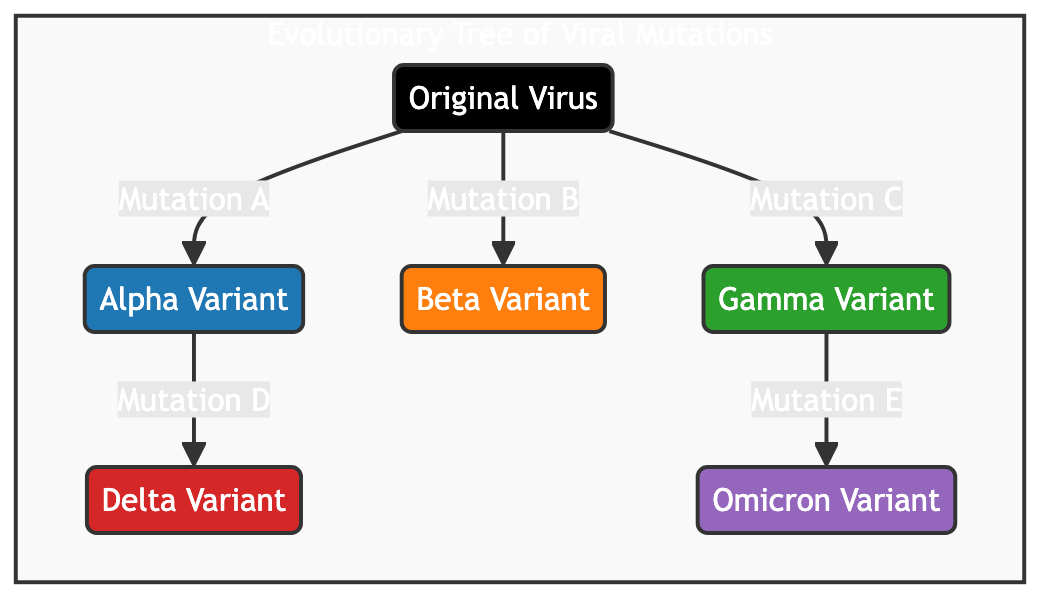What is the original virus labeled as? The original virus is depicted as the root of the evolutionary tree, specifically labeled as "Original Virus."
Answer: Original Virus How many variants are derived from the original virus? The diagram shows five variants branching from the original virus: Alpha, Beta, Gamma, Delta, and Omicron. Therefore, there are a total of five variants derived from the original virus.
Answer: 5 Which mutation leads to the Delta variant? The Delta variant is accessible through the Alpha variant, as indicated by the edge labeled "Mutation D" that connects them.
Answer: Mutation D What mutation is responsible for the emergence of the Beta variant? The connection to the Beta variant from the original virus is labeled "Mutation B," indicating that this mutation is responsible for its emergence.
Answer: Mutation B Which variants are directly derived from Gamma? The only variant that is directly derived from Gamma is the Omicron variant, shown in the diagram by the edge labeled "Mutation E."
Answer: Omicron If the original virus experiences Mutation C, which variant is produced? Following the mutation labeled "Mutation C," the diagram indicates that the Gamma variant is produced from the original virus.
Answer: Gamma Variant How many total mutations are depicted in the diagram? The mutations mapped in the diagram involve five connections: A, B, C, D, and E, thus representing a total of five mutations.
Answer: 5 Which variant has no further mutations after it? The Delta and Omicron variants do not show any further mutations leading from them in the evolutionary tree, meaning they are terminal points.
Answer: Delta Variant and Omicron Variant Which variant results from the Alpha variant? The tree structure shows that the Delta variant results from the Alpha variant through "Mutation D." Thus, the direct outcome of the mutation from Alpha is the Delta variant.
Answer: Delta Variant 